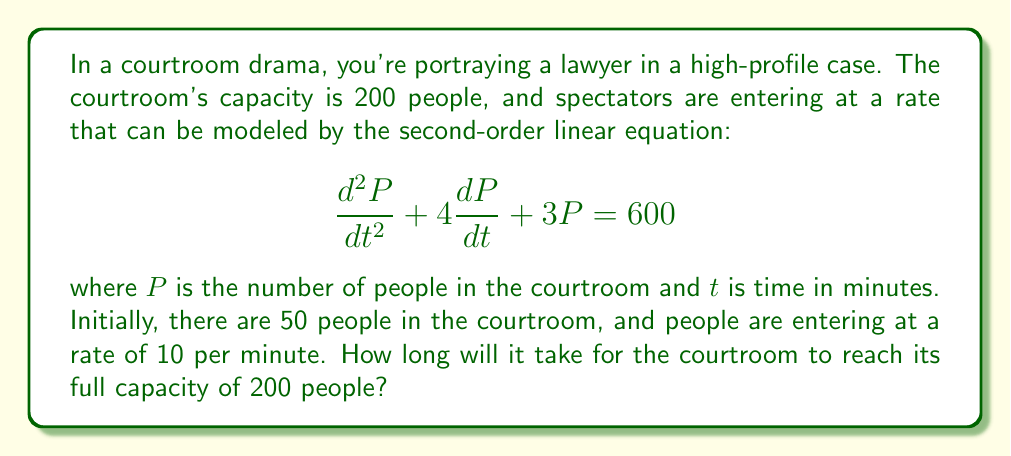Could you help me with this problem? To solve this problem, we need to follow these steps:

1) First, we need to find the general solution to the homogeneous equation:

   $$\frac{d^2P}{dt^2} + 4\frac{dP}{dt} + 3P = 0$$

   The characteristic equation is $r^2 + 4r + 3 = 0$
   Solving this, we get $r = -1$ or $r = -3$

   So, the homogeneous solution is $P_h = c_1e^{-t} + c_2e^{-3t}$

2) Next, we find a particular solution. Given the right side is a constant, we can assume a constant solution:

   $P_p = A$

   Substituting this into the original equation:

   $0 + 0 + 3A = 600$
   $A = 200$

3) The general solution is the sum of the homogeneous and particular solutions:

   $P = c_1e^{-t} + c_2e^{-3t} + 200$

4) Now we use the initial conditions to find $c_1$ and $c_2$:

   At $t = 0$, $P = 50$:
   $50 = c_1 + c_2 + 200$
   $c_1 + c_2 = -150$ (Equation 1)

   At $t = 0$, $\frac{dP}{dt} = 10$:
   $10 = -c_1 - 3c_2$
   $c_1 + 3c_2 = -10$ (Equation 2)

   Solving these simultaneously:
   $c_1 = -110$ and $c_2 = -40$

5) So, our solution is:

   $P = -110e^{-t} - 40e^{-3t} + 200$

6) To find when the courtroom reaches capacity, we solve:

   $200 = -110e^{-t} - 40e^{-3t} + 200$

   This can be solved numerically to get $t \approx 2.30$ minutes.
Answer: It will take approximately 2.30 minutes for the courtroom to reach its full capacity of 200 people. 